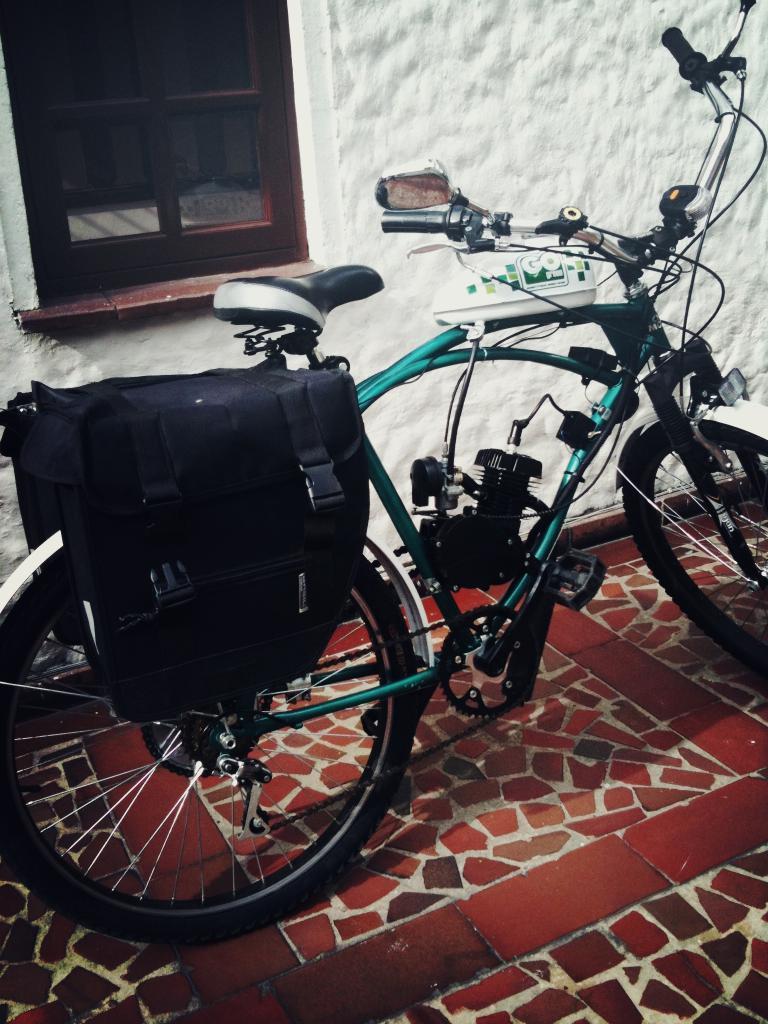Can you describe this image briefly? In this picture we can see a bicycle on the floor and on the bicycle there is a bag. Behind the bicycle there's a wall with a window. 